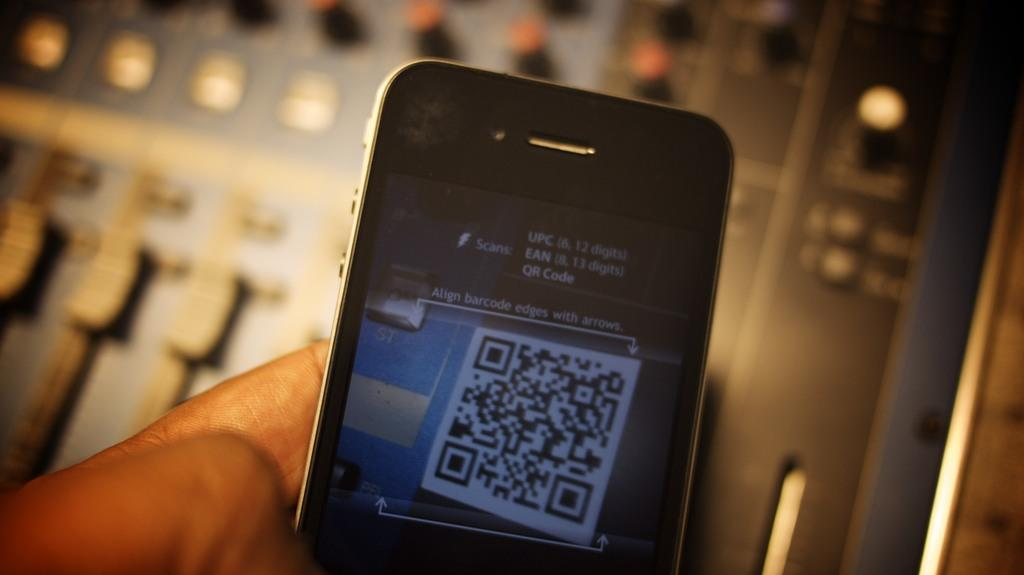Provide a one-sentence caption for the provided image. A phone is held is held up in the process of performing a scan with UPC, EAN and QR code prompt and alignment instruction. 